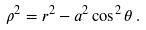<formula> <loc_0><loc_0><loc_500><loc_500>\rho ^ { 2 } = r ^ { 2 } - a ^ { 2 } \cos ^ { 2 } \theta \, .</formula> 